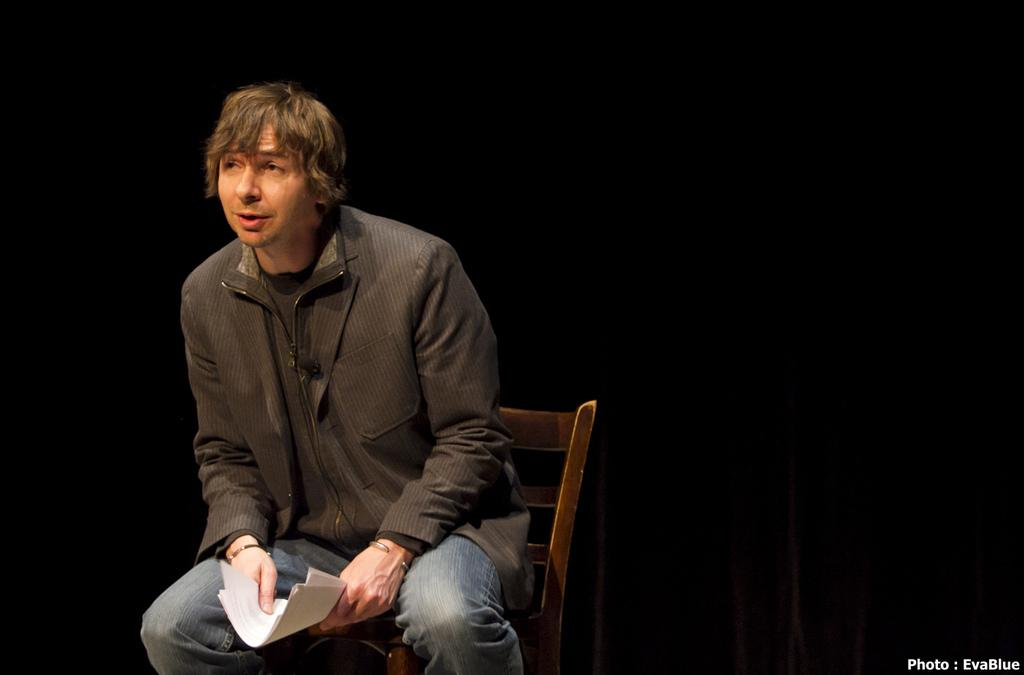What object is present in the image that someone can sit on? There is a chair in the image that someone can sit on. Who is sitting on the chair in the image? A man is sitting on the chair in the image. What is the man holding in the image? The man is holding papers in the image. What color is the wall in the background of the image? The wall in the background of the image is black. What type of sweater is the man wearing in the image? The man is not wearing a sweater in the image; he is holding papers. Is there any poison visible in the image? There is no poison present in the image. 